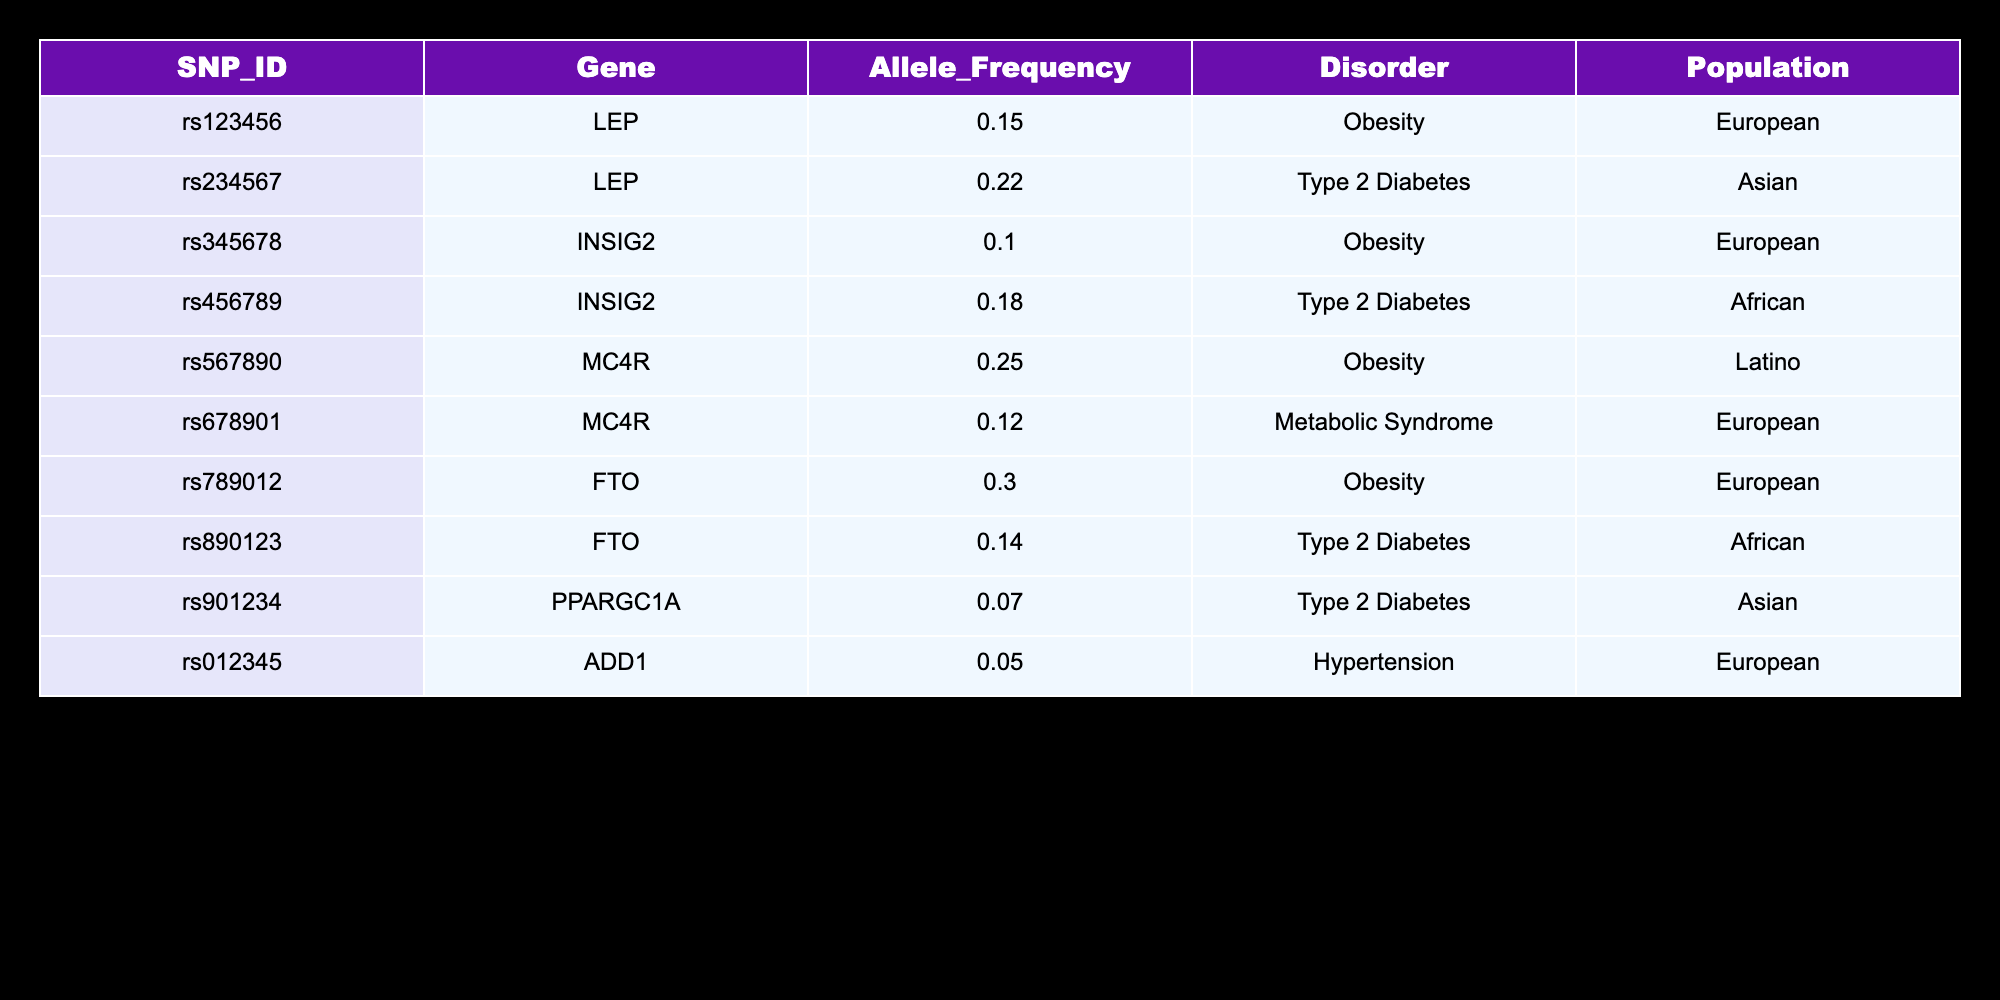What is the highest allele frequency in the table? The allele frequencies listed in the table are 0.15, 0.22, 0.10, 0.18, 0.25, 0.12, 0.30, 0.14, 0.07, and 0.05. By examining these values, the highest frequency is 0.30 associated with SNP ID rs789012.
Answer: 0.30 Which gene is associated with the lowest allele frequency? The allele frequencies for the genes listed are 0.15, 0.22, 0.10, 0.18, 0.25, 0.12, 0.30, 0.14, 0.07, and 0.05. The lowest frequency is 0.05, which corresponds to the gene ADD1.
Answer: ADD1 How many SNPs are linked to the disorder "Type 2 Diabetes"? The table indicates that the following SNPs are associated with "Type 2 Diabetes": rs234567 (LEP), rs456789 (INSIG2), and rs890123 (FTO). This totals three SNPs linked to this disorder.
Answer: 3 What is the average allele frequency of SNPs associated with the gene FTO? The allele frequencies for SNPs associated with gene FTO are 0.30 (rs789012) and 0.14 (rs890123). Thus, the average is calculated as (0.30 + 0.14) / 2 = 0.22.
Answer: 0.22 Is there any SNP associated with "Hypertension" among the listed genes? The table contains one SNP for "Hypertension," which is rs012345 associated with the gene ADD1. Therefore, the answer is yes.
Answer: Yes Which population has the highest frequency of SNPs related to "Obesity"? The SNPs associated with "Obesity" in the table are rs123456 (0.15; European), rs345678 (0.10; European), rs567890 (0.25; Latino), and rs789012 (0.30; European). Adding the frequencies gives (0.15 + 0.10 + 0.25 + 0.30) = 0.80 for the European population, which is the highest compared to Latino (0.25).
Answer: European How many unique genes are represented in the table? The unique genes listed are LEP, INSIG2, MC4R, FTO, PPARGC1A, and ADD1. Counting these gives a total of six unique genes in the data set.
Answer: 6 Are there any SNPs in the African population? By reviewing the table, the SNPs rs456789 (INSIG2) and rs890123 (FTO) are specifically associated with the African population. Thus, the answer to the question is yes.
Answer: Yes What is the sum of allele frequencies of SNPs related to "Obesity"? The SNPs linked to "Obesity" are: rs123456 (0.15), rs345678 (0.10), rs567890 (0.25), and rs789012 (0.30). Summing these values yields (0.15 + 0.10 + 0.25 + 0.30) = 0.80.
Answer: 0.80 